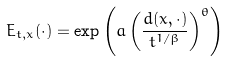<formula> <loc_0><loc_0><loc_500><loc_500>E _ { t , x } ( \cdot ) = \exp \left ( a \left ( \frac { d ( x , \cdot ) } { t ^ { 1 / \beta } } \right ) ^ { \theta } \right )</formula> 